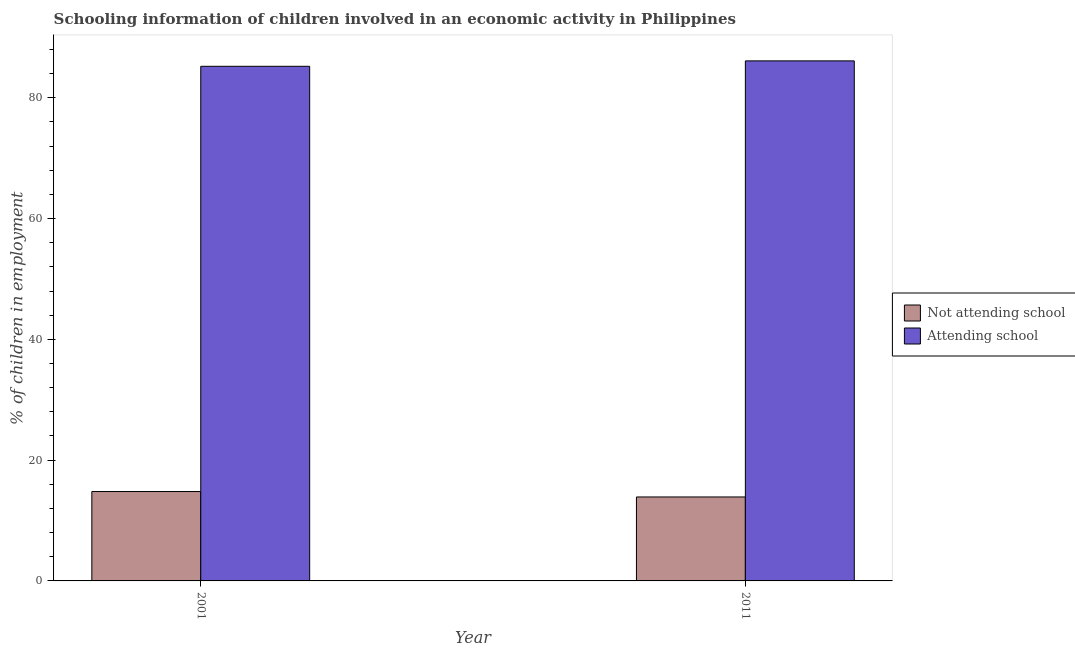How many different coloured bars are there?
Offer a very short reply. 2. How many groups of bars are there?
Give a very brief answer. 2. Are the number of bars per tick equal to the number of legend labels?
Give a very brief answer. Yes. How many bars are there on the 2nd tick from the left?
Keep it short and to the point. 2. How many bars are there on the 1st tick from the right?
Make the answer very short. 2. In how many cases, is the number of bars for a given year not equal to the number of legend labels?
Provide a succinct answer. 0. What is the percentage of employed children who are attending school in 2001?
Provide a short and direct response. 85.2. Across all years, what is the maximum percentage of employed children who are attending school?
Your response must be concise. 86.1. Across all years, what is the minimum percentage of employed children who are attending school?
Offer a very short reply. 85.2. In which year was the percentage of employed children who are attending school minimum?
Your answer should be compact. 2001. What is the total percentage of employed children who are attending school in the graph?
Give a very brief answer. 171.3. What is the difference between the percentage of employed children who are not attending school in 2001 and that in 2011?
Offer a very short reply. 0.9. What is the difference between the percentage of employed children who are not attending school in 2011 and the percentage of employed children who are attending school in 2001?
Keep it short and to the point. -0.9. What is the average percentage of employed children who are not attending school per year?
Your answer should be very brief. 14.35. In the year 2011, what is the difference between the percentage of employed children who are not attending school and percentage of employed children who are attending school?
Give a very brief answer. 0. In how many years, is the percentage of employed children who are attending school greater than 52 %?
Your answer should be compact. 2. What is the ratio of the percentage of employed children who are not attending school in 2001 to that in 2011?
Offer a terse response. 1.06. In how many years, is the percentage of employed children who are attending school greater than the average percentage of employed children who are attending school taken over all years?
Your answer should be very brief. 1. What does the 1st bar from the left in 2001 represents?
Your response must be concise. Not attending school. What does the 2nd bar from the right in 2011 represents?
Keep it short and to the point. Not attending school. How many years are there in the graph?
Your answer should be compact. 2. Does the graph contain any zero values?
Give a very brief answer. No. Does the graph contain grids?
Keep it short and to the point. No. Where does the legend appear in the graph?
Give a very brief answer. Center right. What is the title of the graph?
Provide a short and direct response. Schooling information of children involved in an economic activity in Philippines. What is the label or title of the X-axis?
Offer a very short reply. Year. What is the label or title of the Y-axis?
Your answer should be compact. % of children in employment. What is the % of children in employment of Not attending school in 2001?
Provide a succinct answer. 14.8. What is the % of children in employment in Attending school in 2001?
Give a very brief answer. 85.2. What is the % of children in employment of Not attending school in 2011?
Provide a short and direct response. 13.9. What is the % of children in employment of Attending school in 2011?
Offer a terse response. 86.1. Across all years, what is the maximum % of children in employment of Not attending school?
Offer a very short reply. 14.8. Across all years, what is the maximum % of children in employment of Attending school?
Your response must be concise. 86.1. Across all years, what is the minimum % of children in employment in Not attending school?
Your response must be concise. 13.9. Across all years, what is the minimum % of children in employment in Attending school?
Offer a terse response. 85.2. What is the total % of children in employment of Not attending school in the graph?
Make the answer very short. 28.7. What is the total % of children in employment of Attending school in the graph?
Your response must be concise. 171.3. What is the difference between the % of children in employment in Not attending school in 2001 and that in 2011?
Your answer should be very brief. 0.9. What is the difference between the % of children in employment in Attending school in 2001 and that in 2011?
Offer a terse response. -0.9. What is the difference between the % of children in employment in Not attending school in 2001 and the % of children in employment in Attending school in 2011?
Your answer should be very brief. -71.3. What is the average % of children in employment of Not attending school per year?
Your answer should be compact. 14.35. What is the average % of children in employment of Attending school per year?
Make the answer very short. 85.65. In the year 2001, what is the difference between the % of children in employment in Not attending school and % of children in employment in Attending school?
Provide a short and direct response. -70.4. In the year 2011, what is the difference between the % of children in employment of Not attending school and % of children in employment of Attending school?
Provide a succinct answer. -72.2. What is the ratio of the % of children in employment of Not attending school in 2001 to that in 2011?
Give a very brief answer. 1.06. What is the ratio of the % of children in employment of Attending school in 2001 to that in 2011?
Make the answer very short. 0.99. What is the difference between the highest and the second highest % of children in employment of Not attending school?
Offer a very short reply. 0.9. What is the difference between the highest and the second highest % of children in employment of Attending school?
Offer a terse response. 0.9. What is the difference between the highest and the lowest % of children in employment of Not attending school?
Offer a terse response. 0.9. What is the difference between the highest and the lowest % of children in employment in Attending school?
Keep it short and to the point. 0.9. 